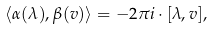Convert formula to latex. <formula><loc_0><loc_0><loc_500><loc_500>\langle \alpha ( \lambda ) , \beta ( v ) \rangle = - 2 \pi i \cdot [ \lambda , v ] ,</formula> 